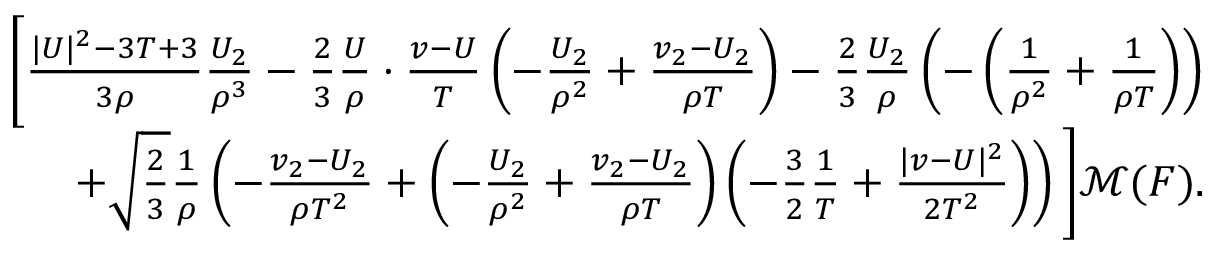Convert formula to latex. <formula><loc_0><loc_0><loc_500><loc_500>\begin{array} { r } { \left [ \frac { | U | ^ { 2 } - 3 T + 3 } { 3 \rho } \frac { U _ { 2 } } { \rho ^ { 3 } } - \frac { 2 } { 3 } \frac { U } { \rho } \cdot \frac { v - U } { T } \left ( - \frac { U _ { 2 } } { \rho ^ { 2 } } + \frac { v _ { 2 } - U _ { 2 } } { \rho T } \right ) - \frac { 2 } { 3 } \frac { U _ { 2 } } { \rho } \left ( - \left ( \frac { 1 } { \rho ^ { 2 } } + \frac { 1 } { \rho T } \right ) \right ) } \\ { + \sqrt { \frac { 2 } { 3 } } \frac { 1 } { \rho } \left ( - \frac { v _ { 2 } - U _ { 2 } } { \rho T ^ { 2 } } + \left ( - \frac { U _ { 2 } } { \rho ^ { 2 } } + \frac { v _ { 2 } - U _ { 2 } } { \rho T } \right ) \left ( - \frac { 3 } { 2 } \frac { 1 } { T } + \frac { | v - U | ^ { 2 } } { 2 T ^ { 2 } } \right ) \right ) \right ] \mathcal { M } ( F ) . } \end{array}</formula> 